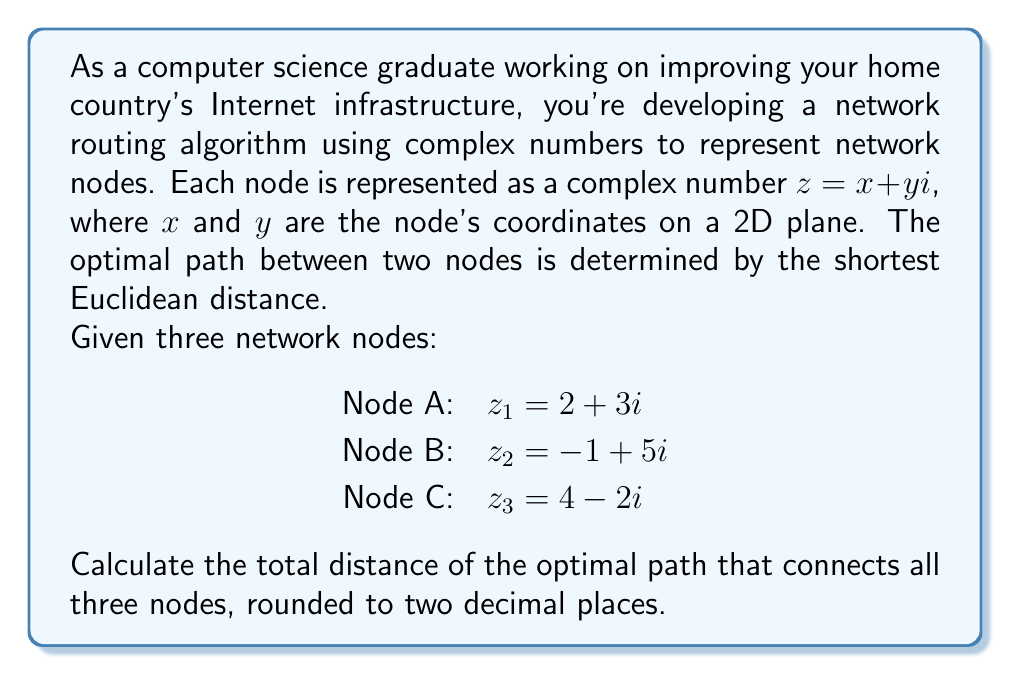Could you help me with this problem? To solve this problem, we need to follow these steps:

1) Calculate the distances between each pair of nodes using the Euclidean distance formula for complex numbers.
2) Determine the shortest path that connects all three nodes.
3) Sum the distances of the optimal path.

Step 1: Calculating distances

The Euclidean distance between two complex numbers $z_1 = a + bi$ and $z_2 = c + di$ is given by:

$$ d = \sqrt{(a-c)^2 + (b-d)^2} = |z_1 - z_2| $$

Let's calculate the distances between each pair of nodes:

Distance AB: $|z_1 - z_2| = |(2+3i) - (-1+5i)| = |3-2i| = \sqrt{3^2 + (-2)^2} = \sqrt{13} \approx 3.61$

Distance BC: $|z_2 - z_3| = |(-1+5i) - (4-2i)| = |-5+7i| = \sqrt{(-5)^2 + 7^2} = \sqrt{74} \approx 8.60$

Distance AC: $|z_1 - z_3| = |(2+3i) - (4-2i)| = |-2+5i| = \sqrt{(-2)^2 + 5^2} = \sqrt{29} \approx 5.39$

Step 2: Determining the shortest path

The shortest path that connects all three nodes will be the sum of the two shortest distances. From our calculations, we can see that:

AB (3.61) + AC (5.39) < AB (3.61) + BC (8.60)
AB (3.61) + AC (5.39) < BC (8.60) + AC (5.39)

Therefore, the optimal path is A -> B -> C or C -> B -> A.

Step 3: Summing the distances

Total distance = Distance AB + Distance AC
               $= \sqrt{13} + \sqrt{29}$
               $\approx 3.61 + 5.39$
               $\approx 9.00$

Rounding to two decimal places, we get 9.00.
Answer: 9.00 